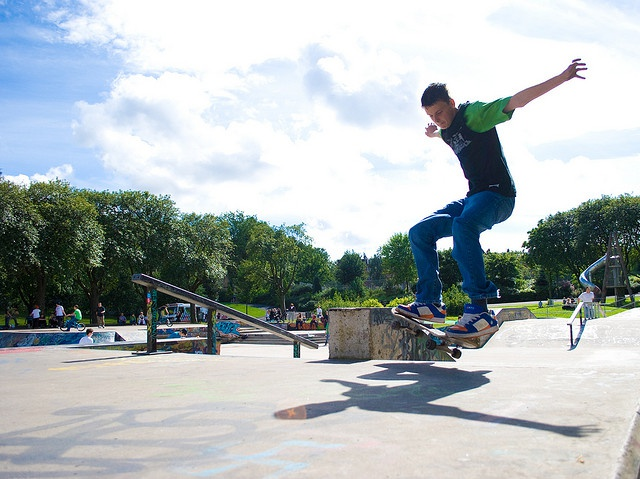Describe the objects in this image and their specific colors. I can see people in lightblue, navy, black, gray, and teal tones, skateboard in lightblue, gray, black, white, and navy tones, people in lightblue, black, gray, navy, and darkgray tones, truck in lightblue, black, gray, blue, and navy tones, and people in lightblue, darkgray, and gray tones in this image. 